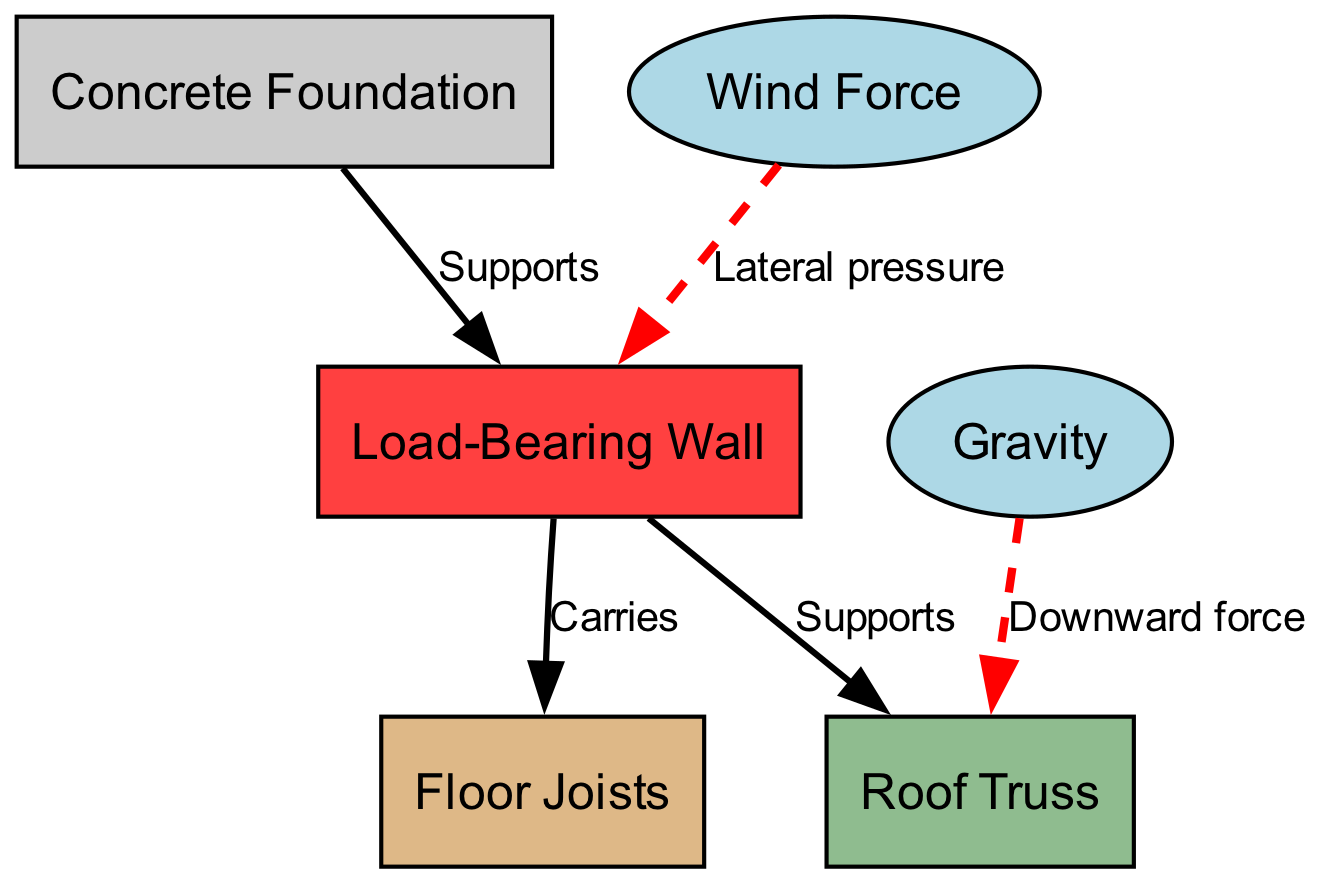What is the top node in the diagram? The top node in this diagram is the roof truss, which is the highest point and carries the downward force from gravity.
Answer: Roof Truss How many nodes are in the diagram? There are six nodes in the diagram: Concrete Foundation, Load-Bearing Wall, Floor Joists, Roof Truss, Wind Force, and Gravity.
Answer: 6 What does the load-bearing wall carry? The load-bearing wall carries the floor joists and receives downward forces from the roof truss, indicating that it plays a crucial role in supporting these structures.
Answer: Floor Joists What type of force does the wind apply to the load-bearing wall? The wind applies lateral pressure to the load-bearing wall, which is illustrated as a direct edge leading from wind force to the load-bearing wall in the diagram.
Answer: Lateral pressure How many forces act on the roof truss node? There are two forces acting on the roof truss node: the downward force from gravity and the supporting load from the load-bearing wall, demonstrating the truss's structural importance.
Answer: 2 What does the foundation support? The foundation supports the load-bearing wall, which means it is the foundational element crucial for the stability of the entire structure above it.
Answer: Load-Bearing Wall What color represents the load-bearing wall? The load-bearing wall is represented in brown1 color in the diagram, differentiating it visually from other structural elements.
Answer: Brown1 Which edge indicates upward support? There are no edges that represent upward support; all shown edges illustrate the downward or lateral forces acting on various nodes. Thus it reflects that the main forces are acting downwards or horizontally.
Answer: None 